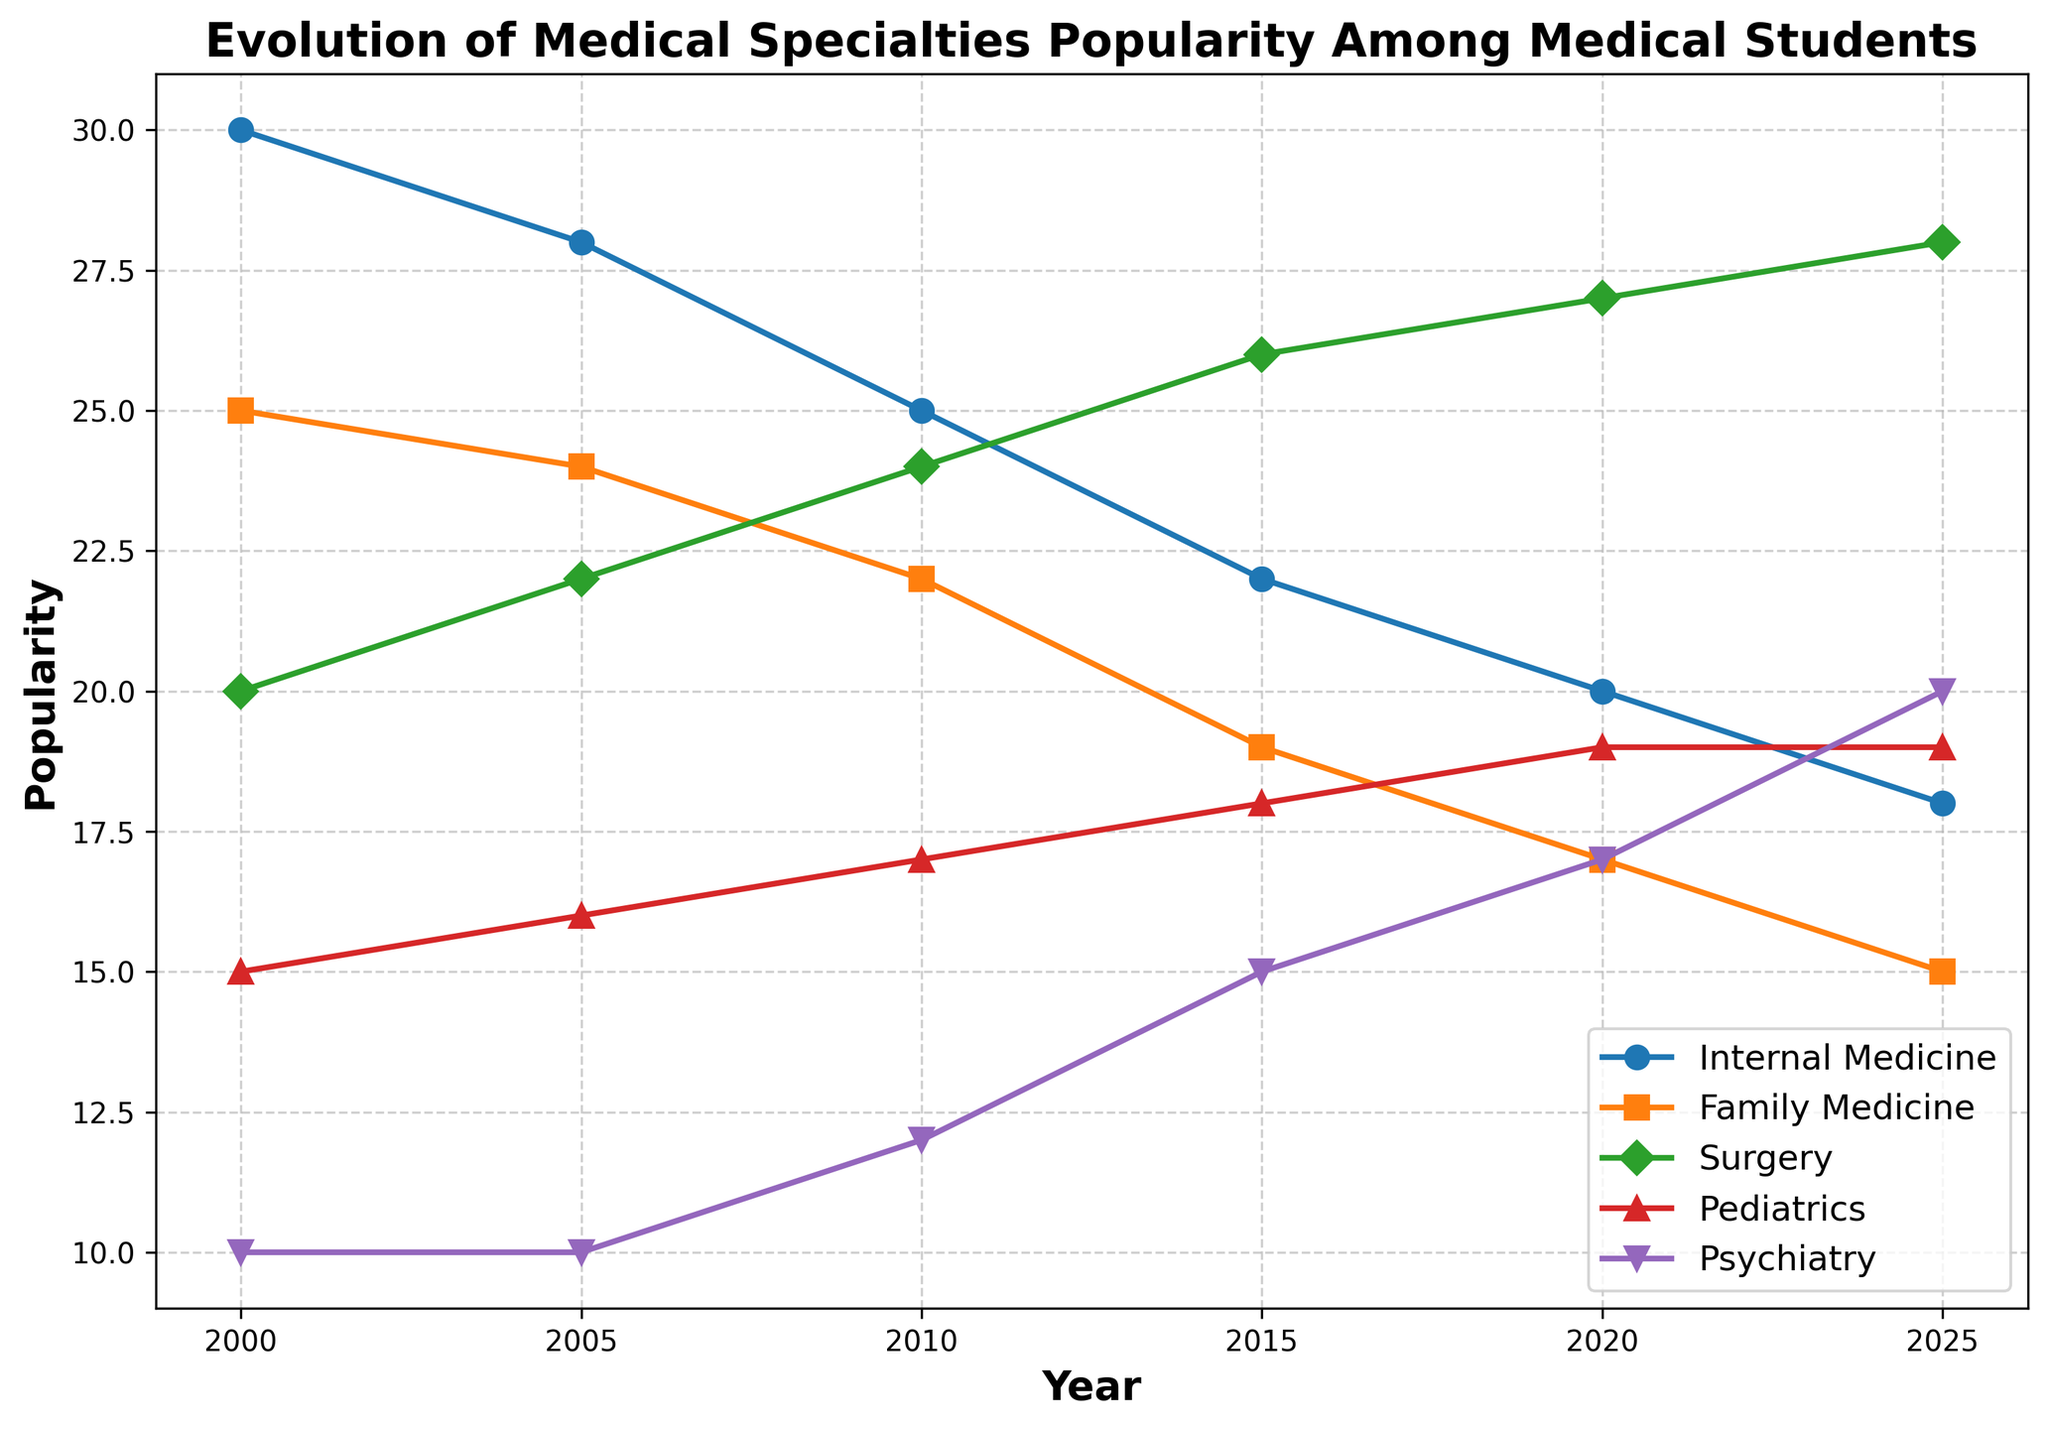What is the most popular medical specialty in 2000? By examining the vertical axis (Popularity) against the labels on the plot, the highest point in the year 2000 corresponds to Internal Medicine with a popularity of 30.
Answer: Internal Medicine Between 2000 and 2025, which specialty shows the most significant increase in popularity? Comparing the popularity values of all specialties from 2000 to 2025, Psychiatry increases from 10 to 20, marking an increase of 10 points. This is higher than any other specialty.
Answer: Psychiatry Which specialties have a consistent upward trend in popularity over the years? Observing the plot lines, Pediatrics and Psychiatry consistently increase in popularity with each subsequent year.
Answer: Pediatrics, Psychiatry What is the average popularity of Family Medicine from 2000 to 2025? Summing up Family Medicine's popularity over the years is 25 + 24 + 22 + 19 + 17 + 15 = 122. Dividing by 6, the number of data points, we get 122/6 ≈ 20.33.
Answer: 20.33 How does the popularity of Surgery change from 2000 to 2025? Surgery's popularity starts at 20 in 2000, then increases to 22 in 2005, 24 in 2010, 26 in 2015, 27 in 2020, and finally 28 in 2025, indicating a consistent rise over the period.
Answer: It increases In what year does Psychiatry surpass both Internal Medicine and Family Medicine in popularity? Observing the trends, Psychiatry surpasses Internal Medicine and Family Medicine in 2025, reaching a popularity value of 20, while Internal Medicine and Family Medicine are at 18 and 15, respectively.
Answer: 2025 Which specialty had the highest popularity peak over the entire period? By scanning the vertical peaks, Internal Medicine had the highest peak popularity of 30 in 2000, which no other specialty surpassed.
Answer: Internal Medicine How does the popularity of Internal Medicine change between 2000 and 2025? The popularity of Internal Medicine decreases gradually from 30 in 2000 to 18 in 2025.
Answer: It decreases What is the difference in popularity between Surgery and Pediatrics in 2020? In 2020, Surgery has a popularity of 27 and Pediatrics has 19. The difference is 27 - 19 = 8.
Answer: 8 Which specialty showed the smallest overall variation in popularity from 2000 to 2025? Psychiatry's popularity changes from 10 to 20, showing a variation of 10. Other specialties have larger variations, so Psychiatry's variation is the smallest.
Answer: Psychiatry 